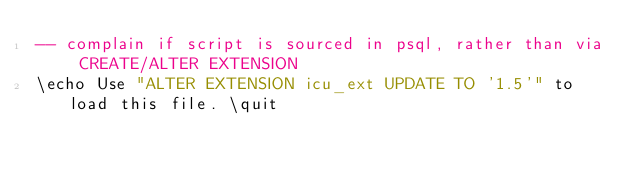Convert code to text. <code><loc_0><loc_0><loc_500><loc_500><_SQL_>-- complain if script is sourced in psql, rather than via CREATE/ALTER EXTENSION
\echo Use "ALTER EXTENSION icu_ext UPDATE TO '1.5'" to load this file. \quit
</code> 